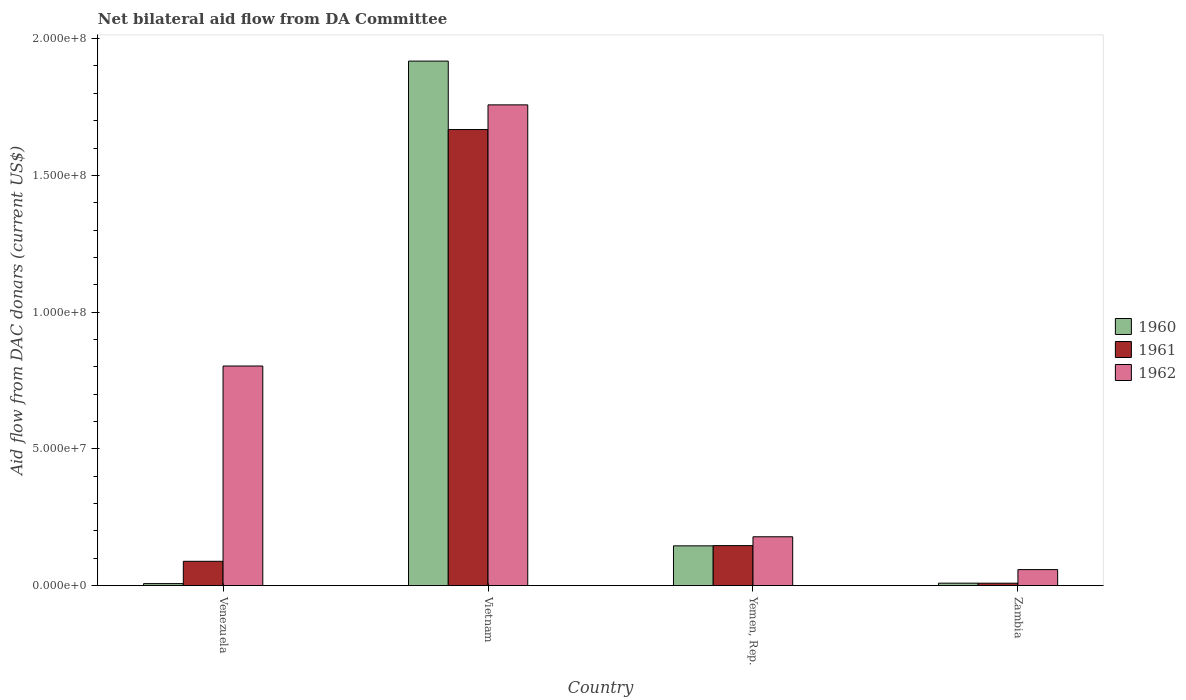How many different coloured bars are there?
Make the answer very short. 3. How many groups of bars are there?
Keep it short and to the point. 4. Are the number of bars on each tick of the X-axis equal?
Offer a very short reply. Yes. How many bars are there on the 3rd tick from the right?
Provide a succinct answer. 3. What is the label of the 4th group of bars from the left?
Provide a short and direct response. Zambia. In how many cases, is the number of bars for a given country not equal to the number of legend labels?
Provide a succinct answer. 0. What is the aid flow in in 1962 in Vietnam?
Keep it short and to the point. 1.76e+08. Across all countries, what is the maximum aid flow in in 1960?
Offer a very short reply. 1.92e+08. Across all countries, what is the minimum aid flow in in 1962?
Offer a terse response. 5.88e+06. In which country was the aid flow in in 1962 maximum?
Offer a terse response. Vietnam. In which country was the aid flow in in 1960 minimum?
Provide a short and direct response. Venezuela. What is the total aid flow in in 1960 in the graph?
Provide a short and direct response. 2.08e+08. What is the difference between the aid flow in in 1962 in Yemen, Rep. and that in Zambia?
Give a very brief answer. 1.20e+07. What is the difference between the aid flow in in 1962 in Vietnam and the aid flow in in 1961 in Venezuela?
Your answer should be compact. 1.67e+08. What is the average aid flow in in 1962 per country?
Provide a short and direct response. 7.00e+07. What is the difference between the aid flow in of/in 1960 and aid flow in of/in 1962 in Vietnam?
Provide a succinct answer. 1.60e+07. In how many countries, is the aid flow in in 1960 greater than 130000000 US$?
Make the answer very short. 1. What is the ratio of the aid flow in in 1960 in Venezuela to that in Zambia?
Ensure brevity in your answer.  0.83. What is the difference between the highest and the second highest aid flow in in 1961?
Give a very brief answer. 1.52e+08. What is the difference between the highest and the lowest aid flow in in 1960?
Provide a short and direct response. 1.91e+08. In how many countries, is the aid flow in in 1961 greater than the average aid flow in in 1961 taken over all countries?
Offer a terse response. 1. Is the sum of the aid flow in in 1960 in Venezuela and Yemen, Rep. greater than the maximum aid flow in in 1961 across all countries?
Ensure brevity in your answer.  No. What does the 3rd bar from the left in Zambia represents?
Ensure brevity in your answer.  1962. What does the 2nd bar from the right in Yemen, Rep. represents?
Keep it short and to the point. 1961. What is the difference between two consecutive major ticks on the Y-axis?
Your response must be concise. 5.00e+07. Does the graph contain any zero values?
Your response must be concise. No. Does the graph contain grids?
Make the answer very short. No. What is the title of the graph?
Your answer should be very brief. Net bilateral aid flow from DA Committee. What is the label or title of the Y-axis?
Offer a terse response. Aid flow from DAC donars (current US$). What is the Aid flow from DAC donars (current US$) of 1960 in Venezuela?
Offer a terse response. 7.60e+05. What is the Aid flow from DAC donars (current US$) of 1961 in Venezuela?
Make the answer very short. 8.92e+06. What is the Aid flow from DAC donars (current US$) in 1962 in Venezuela?
Make the answer very short. 8.03e+07. What is the Aid flow from DAC donars (current US$) of 1960 in Vietnam?
Offer a terse response. 1.92e+08. What is the Aid flow from DAC donars (current US$) in 1961 in Vietnam?
Make the answer very short. 1.67e+08. What is the Aid flow from DAC donars (current US$) in 1962 in Vietnam?
Ensure brevity in your answer.  1.76e+08. What is the Aid flow from DAC donars (current US$) of 1960 in Yemen, Rep.?
Offer a very short reply. 1.46e+07. What is the Aid flow from DAC donars (current US$) in 1961 in Yemen, Rep.?
Keep it short and to the point. 1.46e+07. What is the Aid flow from DAC donars (current US$) in 1962 in Yemen, Rep.?
Your response must be concise. 1.79e+07. What is the Aid flow from DAC donars (current US$) of 1960 in Zambia?
Offer a terse response. 9.20e+05. What is the Aid flow from DAC donars (current US$) of 1961 in Zambia?
Make the answer very short. 9.10e+05. What is the Aid flow from DAC donars (current US$) in 1962 in Zambia?
Make the answer very short. 5.88e+06. Across all countries, what is the maximum Aid flow from DAC donars (current US$) in 1960?
Your answer should be very brief. 1.92e+08. Across all countries, what is the maximum Aid flow from DAC donars (current US$) in 1961?
Make the answer very short. 1.67e+08. Across all countries, what is the maximum Aid flow from DAC donars (current US$) in 1962?
Provide a short and direct response. 1.76e+08. Across all countries, what is the minimum Aid flow from DAC donars (current US$) of 1960?
Keep it short and to the point. 7.60e+05. Across all countries, what is the minimum Aid flow from DAC donars (current US$) of 1961?
Offer a very short reply. 9.10e+05. Across all countries, what is the minimum Aid flow from DAC donars (current US$) of 1962?
Ensure brevity in your answer.  5.88e+06. What is the total Aid flow from DAC donars (current US$) in 1960 in the graph?
Give a very brief answer. 2.08e+08. What is the total Aid flow from DAC donars (current US$) in 1961 in the graph?
Provide a succinct answer. 1.91e+08. What is the total Aid flow from DAC donars (current US$) in 1962 in the graph?
Make the answer very short. 2.80e+08. What is the difference between the Aid flow from DAC donars (current US$) in 1960 in Venezuela and that in Vietnam?
Your answer should be very brief. -1.91e+08. What is the difference between the Aid flow from DAC donars (current US$) in 1961 in Venezuela and that in Vietnam?
Your answer should be very brief. -1.58e+08. What is the difference between the Aid flow from DAC donars (current US$) in 1962 in Venezuela and that in Vietnam?
Your answer should be compact. -9.55e+07. What is the difference between the Aid flow from DAC donars (current US$) in 1960 in Venezuela and that in Yemen, Rep.?
Ensure brevity in your answer.  -1.38e+07. What is the difference between the Aid flow from DAC donars (current US$) in 1961 in Venezuela and that in Yemen, Rep.?
Give a very brief answer. -5.73e+06. What is the difference between the Aid flow from DAC donars (current US$) in 1962 in Venezuela and that in Yemen, Rep.?
Give a very brief answer. 6.24e+07. What is the difference between the Aid flow from DAC donars (current US$) in 1961 in Venezuela and that in Zambia?
Your response must be concise. 8.01e+06. What is the difference between the Aid flow from DAC donars (current US$) in 1962 in Venezuela and that in Zambia?
Ensure brevity in your answer.  7.44e+07. What is the difference between the Aid flow from DAC donars (current US$) in 1960 in Vietnam and that in Yemen, Rep.?
Your response must be concise. 1.77e+08. What is the difference between the Aid flow from DAC donars (current US$) in 1961 in Vietnam and that in Yemen, Rep.?
Provide a succinct answer. 1.52e+08. What is the difference between the Aid flow from DAC donars (current US$) of 1962 in Vietnam and that in Yemen, Rep.?
Ensure brevity in your answer.  1.58e+08. What is the difference between the Aid flow from DAC donars (current US$) in 1960 in Vietnam and that in Zambia?
Your response must be concise. 1.91e+08. What is the difference between the Aid flow from DAC donars (current US$) of 1961 in Vietnam and that in Zambia?
Give a very brief answer. 1.66e+08. What is the difference between the Aid flow from DAC donars (current US$) of 1962 in Vietnam and that in Zambia?
Give a very brief answer. 1.70e+08. What is the difference between the Aid flow from DAC donars (current US$) in 1960 in Yemen, Rep. and that in Zambia?
Your answer should be compact. 1.36e+07. What is the difference between the Aid flow from DAC donars (current US$) in 1961 in Yemen, Rep. and that in Zambia?
Your answer should be very brief. 1.37e+07. What is the difference between the Aid flow from DAC donars (current US$) in 1962 in Yemen, Rep. and that in Zambia?
Offer a terse response. 1.20e+07. What is the difference between the Aid flow from DAC donars (current US$) of 1960 in Venezuela and the Aid flow from DAC donars (current US$) of 1961 in Vietnam?
Provide a short and direct response. -1.66e+08. What is the difference between the Aid flow from DAC donars (current US$) in 1960 in Venezuela and the Aid flow from DAC donars (current US$) in 1962 in Vietnam?
Your answer should be compact. -1.75e+08. What is the difference between the Aid flow from DAC donars (current US$) in 1961 in Venezuela and the Aid flow from DAC donars (current US$) in 1962 in Vietnam?
Offer a very short reply. -1.67e+08. What is the difference between the Aid flow from DAC donars (current US$) of 1960 in Venezuela and the Aid flow from DAC donars (current US$) of 1961 in Yemen, Rep.?
Your answer should be compact. -1.39e+07. What is the difference between the Aid flow from DAC donars (current US$) of 1960 in Venezuela and the Aid flow from DAC donars (current US$) of 1962 in Yemen, Rep.?
Your response must be concise. -1.71e+07. What is the difference between the Aid flow from DAC donars (current US$) in 1961 in Venezuela and the Aid flow from DAC donars (current US$) in 1962 in Yemen, Rep.?
Provide a short and direct response. -8.96e+06. What is the difference between the Aid flow from DAC donars (current US$) in 1960 in Venezuela and the Aid flow from DAC donars (current US$) in 1962 in Zambia?
Your response must be concise. -5.12e+06. What is the difference between the Aid flow from DAC donars (current US$) in 1961 in Venezuela and the Aid flow from DAC donars (current US$) in 1962 in Zambia?
Provide a short and direct response. 3.04e+06. What is the difference between the Aid flow from DAC donars (current US$) of 1960 in Vietnam and the Aid flow from DAC donars (current US$) of 1961 in Yemen, Rep.?
Offer a very short reply. 1.77e+08. What is the difference between the Aid flow from DAC donars (current US$) of 1960 in Vietnam and the Aid flow from DAC donars (current US$) of 1962 in Yemen, Rep.?
Provide a succinct answer. 1.74e+08. What is the difference between the Aid flow from DAC donars (current US$) in 1961 in Vietnam and the Aid flow from DAC donars (current US$) in 1962 in Yemen, Rep.?
Offer a very short reply. 1.49e+08. What is the difference between the Aid flow from DAC donars (current US$) in 1960 in Vietnam and the Aid flow from DAC donars (current US$) in 1961 in Zambia?
Ensure brevity in your answer.  1.91e+08. What is the difference between the Aid flow from DAC donars (current US$) of 1960 in Vietnam and the Aid flow from DAC donars (current US$) of 1962 in Zambia?
Keep it short and to the point. 1.86e+08. What is the difference between the Aid flow from DAC donars (current US$) of 1961 in Vietnam and the Aid flow from DAC donars (current US$) of 1962 in Zambia?
Offer a very short reply. 1.61e+08. What is the difference between the Aid flow from DAC donars (current US$) of 1960 in Yemen, Rep. and the Aid flow from DAC donars (current US$) of 1961 in Zambia?
Offer a terse response. 1.36e+07. What is the difference between the Aid flow from DAC donars (current US$) of 1960 in Yemen, Rep. and the Aid flow from DAC donars (current US$) of 1962 in Zambia?
Offer a very short reply. 8.68e+06. What is the difference between the Aid flow from DAC donars (current US$) of 1961 in Yemen, Rep. and the Aid flow from DAC donars (current US$) of 1962 in Zambia?
Your answer should be compact. 8.77e+06. What is the average Aid flow from DAC donars (current US$) of 1960 per country?
Your response must be concise. 5.20e+07. What is the average Aid flow from DAC donars (current US$) in 1961 per country?
Your answer should be compact. 4.78e+07. What is the average Aid flow from DAC donars (current US$) of 1962 per country?
Keep it short and to the point. 7.00e+07. What is the difference between the Aid flow from DAC donars (current US$) in 1960 and Aid flow from DAC donars (current US$) in 1961 in Venezuela?
Keep it short and to the point. -8.16e+06. What is the difference between the Aid flow from DAC donars (current US$) in 1960 and Aid flow from DAC donars (current US$) in 1962 in Venezuela?
Provide a short and direct response. -7.96e+07. What is the difference between the Aid flow from DAC donars (current US$) in 1961 and Aid flow from DAC donars (current US$) in 1962 in Venezuela?
Give a very brief answer. -7.14e+07. What is the difference between the Aid flow from DAC donars (current US$) of 1960 and Aid flow from DAC donars (current US$) of 1961 in Vietnam?
Ensure brevity in your answer.  2.50e+07. What is the difference between the Aid flow from DAC donars (current US$) of 1960 and Aid flow from DAC donars (current US$) of 1962 in Vietnam?
Ensure brevity in your answer.  1.60e+07. What is the difference between the Aid flow from DAC donars (current US$) of 1961 and Aid flow from DAC donars (current US$) of 1962 in Vietnam?
Provide a short and direct response. -9.02e+06. What is the difference between the Aid flow from DAC donars (current US$) of 1960 and Aid flow from DAC donars (current US$) of 1962 in Yemen, Rep.?
Provide a succinct answer. -3.32e+06. What is the difference between the Aid flow from DAC donars (current US$) of 1961 and Aid flow from DAC donars (current US$) of 1962 in Yemen, Rep.?
Your answer should be very brief. -3.23e+06. What is the difference between the Aid flow from DAC donars (current US$) in 1960 and Aid flow from DAC donars (current US$) in 1962 in Zambia?
Your answer should be very brief. -4.96e+06. What is the difference between the Aid flow from DAC donars (current US$) in 1961 and Aid flow from DAC donars (current US$) in 1962 in Zambia?
Your response must be concise. -4.97e+06. What is the ratio of the Aid flow from DAC donars (current US$) of 1960 in Venezuela to that in Vietnam?
Offer a very short reply. 0. What is the ratio of the Aid flow from DAC donars (current US$) of 1961 in Venezuela to that in Vietnam?
Your answer should be compact. 0.05. What is the ratio of the Aid flow from DAC donars (current US$) in 1962 in Venezuela to that in Vietnam?
Your answer should be very brief. 0.46. What is the ratio of the Aid flow from DAC donars (current US$) of 1960 in Venezuela to that in Yemen, Rep.?
Offer a very short reply. 0.05. What is the ratio of the Aid flow from DAC donars (current US$) in 1961 in Venezuela to that in Yemen, Rep.?
Ensure brevity in your answer.  0.61. What is the ratio of the Aid flow from DAC donars (current US$) of 1962 in Venezuela to that in Yemen, Rep.?
Offer a terse response. 4.49. What is the ratio of the Aid flow from DAC donars (current US$) of 1960 in Venezuela to that in Zambia?
Your response must be concise. 0.83. What is the ratio of the Aid flow from DAC donars (current US$) in 1961 in Venezuela to that in Zambia?
Offer a terse response. 9.8. What is the ratio of the Aid flow from DAC donars (current US$) in 1962 in Venezuela to that in Zambia?
Your answer should be compact. 13.66. What is the ratio of the Aid flow from DAC donars (current US$) of 1960 in Vietnam to that in Yemen, Rep.?
Make the answer very short. 13.17. What is the ratio of the Aid flow from DAC donars (current US$) in 1961 in Vietnam to that in Yemen, Rep.?
Provide a short and direct response. 11.38. What is the ratio of the Aid flow from DAC donars (current US$) in 1962 in Vietnam to that in Yemen, Rep.?
Your answer should be very brief. 9.83. What is the ratio of the Aid flow from DAC donars (current US$) in 1960 in Vietnam to that in Zambia?
Keep it short and to the point. 208.46. What is the ratio of the Aid flow from DAC donars (current US$) of 1961 in Vietnam to that in Zambia?
Make the answer very short. 183.25. What is the ratio of the Aid flow from DAC donars (current US$) in 1962 in Vietnam to that in Zambia?
Make the answer very short. 29.89. What is the ratio of the Aid flow from DAC donars (current US$) of 1960 in Yemen, Rep. to that in Zambia?
Offer a terse response. 15.83. What is the ratio of the Aid flow from DAC donars (current US$) of 1961 in Yemen, Rep. to that in Zambia?
Make the answer very short. 16.1. What is the ratio of the Aid flow from DAC donars (current US$) in 1962 in Yemen, Rep. to that in Zambia?
Offer a terse response. 3.04. What is the difference between the highest and the second highest Aid flow from DAC donars (current US$) in 1960?
Provide a succinct answer. 1.77e+08. What is the difference between the highest and the second highest Aid flow from DAC donars (current US$) of 1961?
Make the answer very short. 1.52e+08. What is the difference between the highest and the second highest Aid flow from DAC donars (current US$) in 1962?
Ensure brevity in your answer.  9.55e+07. What is the difference between the highest and the lowest Aid flow from DAC donars (current US$) in 1960?
Ensure brevity in your answer.  1.91e+08. What is the difference between the highest and the lowest Aid flow from DAC donars (current US$) of 1961?
Provide a short and direct response. 1.66e+08. What is the difference between the highest and the lowest Aid flow from DAC donars (current US$) of 1962?
Provide a succinct answer. 1.70e+08. 